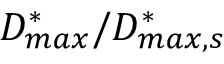Convert formula to latex. <formula><loc_0><loc_0><loc_500><loc_500>D _ { \max } ^ { * } / D _ { \max , s } ^ { * }</formula> 